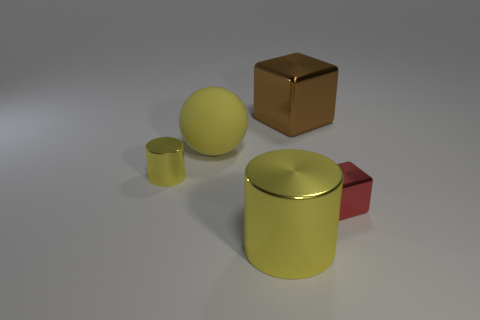Add 3 big red matte objects. How many objects exist? 8 Subtract 1 cylinders. How many cylinders are left? 1 Subtract all blocks. How many objects are left? 3 Subtract all green balls. Subtract all yellow cubes. How many balls are left? 1 Subtract all gray balls. How many red cubes are left? 1 Subtract all large blue matte blocks. Subtract all large shiny objects. How many objects are left? 3 Add 2 large brown things. How many large brown things are left? 3 Add 3 big yellow shiny things. How many big yellow shiny things exist? 4 Subtract 0 cyan cylinders. How many objects are left? 5 